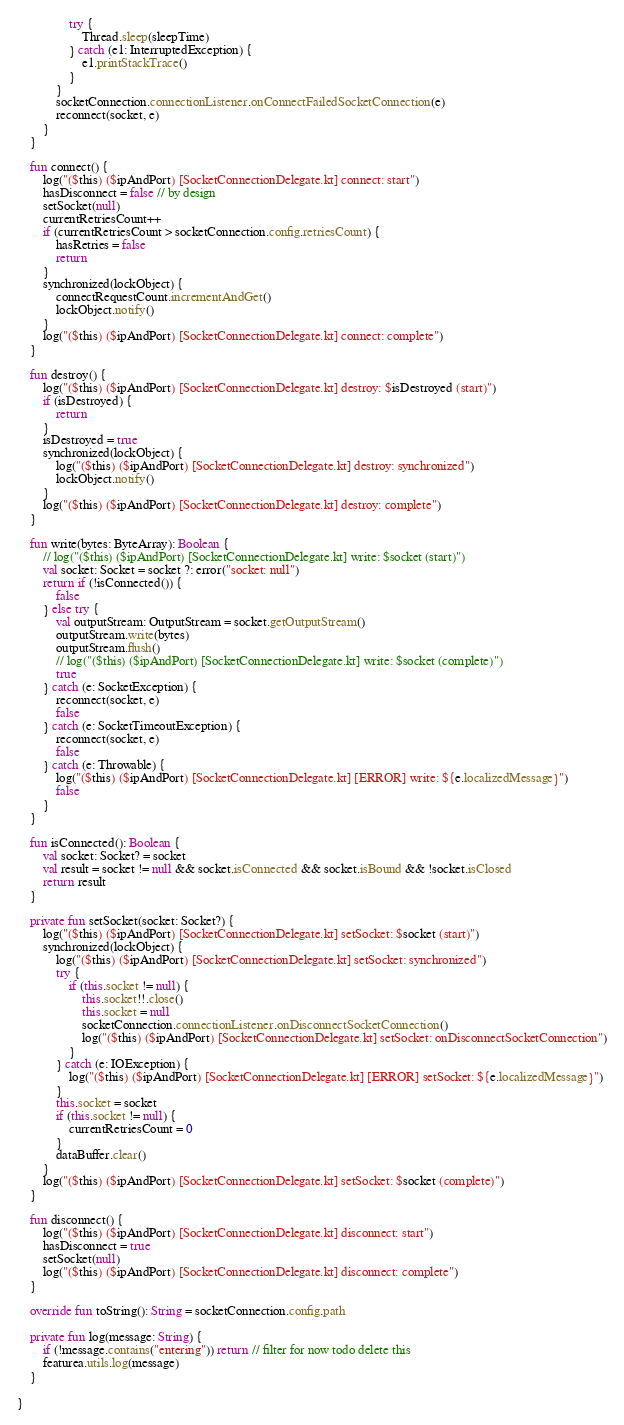Convert code to text. <code><loc_0><loc_0><loc_500><loc_500><_Kotlin_>                try {
                    Thread.sleep(sleepTime)
                } catch (e1: InterruptedException) {
                    e1.printStackTrace()
                }
            }
            socketConnection.connectionListener.onConnectFailedSocketConnection(e)
            reconnect(socket, e)
        }
    }

    fun connect() {
        log("($this) ($ipAndPort) [SocketConnectionDelegate.kt] connect: start")
        hasDisconnect = false // by design
        setSocket(null)
        currentRetriesCount++
        if (currentRetriesCount > socketConnection.config.retriesCount) {
            hasRetries = false
            return
        }
        synchronized(lockObject) {
            connectRequestCount.incrementAndGet()
            lockObject.notify()
        }
        log("($this) ($ipAndPort) [SocketConnectionDelegate.kt] connect: complete")
    }

    fun destroy() {
        log("($this) ($ipAndPort) [SocketConnectionDelegate.kt] destroy: $isDestroyed (start)")
        if (isDestroyed) {
            return
        }
        isDestroyed = true
        synchronized(lockObject) {
            log("($this) ($ipAndPort) [SocketConnectionDelegate.kt] destroy: synchronized")
            lockObject.notify()
        }
        log("($this) ($ipAndPort) [SocketConnectionDelegate.kt] destroy: complete")
    }

    fun write(bytes: ByteArray): Boolean {
        // log("($this) ($ipAndPort) [SocketConnectionDelegate.kt] write: $socket (start)")
        val socket: Socket = socket ?: error("socket: null")
        return if (!isConnected()) {
            false
        } else try {
            val outputStream: OutputStream = socket.getOutputStream()
            outputStream.write(bytes)
            outputStream.flush()
            // log("($this) ($ipAndPort) [SocketConnectionDelegate.kt] write: $socket (complete)")
            true
        } catch (e: SocketException) {
            reconnect(socket, e)
            false
        } catch (e: SocketTimeoutException) {
            reconnect(socket, e)
            false
        } catch (e: Throwable) {
            log("($this) ($ipAndPort) [SocketConnectionDelegate.kt] [ERROR] write: ${e.localizedMessage}")
            false
        }
    }

    fun isConnected(): Boolean {
        val socket: Socket? = socket
        val result = socket != null && socket.isConnected && socket.isBound && !socket.isClosed
        return result
    }

    private fun setSocket(socket: Socket?) {
        log("($this) ($ipAndPort) [SocketConnectionDelegate.kt] setSocket: $socket (start)")
        synchronized(lockObject) {
            log("($this) ($ipAndPort) [SocketConnectionDelegate.kt] setSocket: synchronized")
            try {
                if (this.socket != null) {
                    this.socket!!.close()
                    this.socket = null
                    socketConnection.connectionListener.onDisconnectSocketConnection()
                    log("($this) ($ipAndPort) [SocketConnectionDelegate.kt] setSocket: onDisconnectSocketConnection")
                }
            } catch (e: IOException) {
                log("($this) ($ipAndPort) [SocketConnectionDelegate.kt] [ERROR] setSocket: ${e.localizedMessage}")
            }
            this.socket = socket
            if (this.socket != null) {
                currentRetriesCount = 0
            }
            dataBuffer.clear()
        }
        log("($this) ($ipAndPort) [SocketConnectionDelegate.kt] setSocket: $socket (complete)")
    }

    fun disconnect() {
        log("($this) ($ipAndPort) [SocketConnectionDelegate.kt] disconnect: start")
        hasDisconnect = true
        setSocket(null)
        log("($this) ($ipAndPort) [SocketConnectionDelegate.kt] disconnect: complete")
    }

    override fun toString(): String = socketConnection.config.path

    private fun log(message: String) {
        if (!message.contains("entering")) return // filter for now todo delete this
        featurea.utils.log(message)
    }

}
</code> 